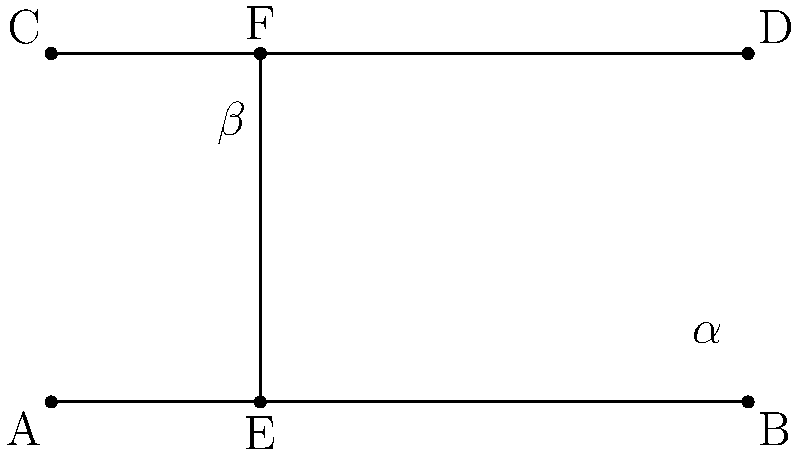In the diagram, lines AB and CD are parallel, and line EF intersects both of them. If the measure of angle $\alpha$ is $65^\circ$, what is the measure of angle $\beta$? Explain your reasoning using the concepts of corresponding and alternate angles. To solve this problem, we'll follow these steps:

1) First, recall that when a line intersects two parallel lines, it creates several pairs of equal angles:
   - Corresponding angles are equal
   - Alternate interior angles are equal
   - Alternate exterior angles are equal

2) In this diagram, angle $\alpha$ and angle $\beta$ are alternate interior angles. They are formed on opposite sides of the transversal (EF) and between the two parallel lines (AB and CD).

3) According to the alternate interior angles theorem, when a transversal crosses two parallel lines, the alternate interior angles are congruent (equal in measure).

4) Therefore, we can conclude that:

   $$\alpha = \beta$$

5) We are given that the measure of angle $\alpha$ is $65^\circ$.

6) Since $\alpha = \beta$, we can substitute this value:

   $$\beta = 65^\circ$$

Thus, the measure of angle $\beta$ is also $65^\circ$.
Answer: $65^\circ$ 